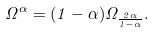Convert formula to latex. <formula><loc_0><loc_0><loc_500><loc_500>\Omega ^ { \alpha } = ( 1 - \alpha ) \Omega _ { \frac { 2 \alpha } { 1 - \alpha } } .</formula> 